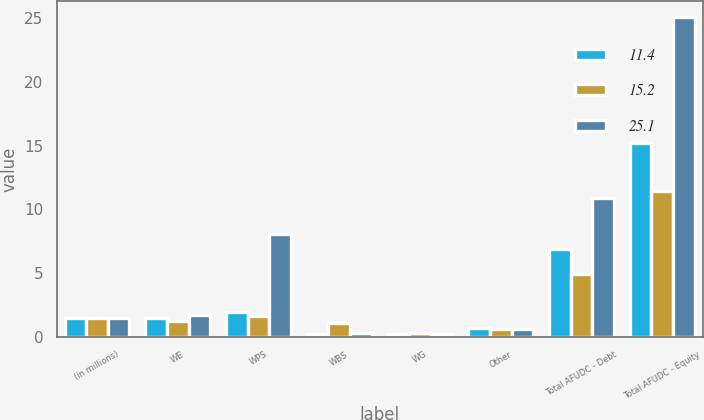Convert chart. <chart><loc_0><loc_0><loc_500><loc_500><stacked_bar_chart><ecel><fcel>(in millions)<fcel>WE<fcel>WPS<fcel>WBS<fcel>WG<fcel>Other<fcel>Total AFUDC - Debt<fcel>Total AFUDC - Equity<nl><fcel>11.4<fcel>1.5<fcel>1.5<fcel>1.9<fcel>0.2<fcel>0.2<fcel>0.7<fcel>6.9<fcel>15.2<nl><fcel>15.2<fcel>1.5<fcel>1.2<fcel>1.6<fcel>1.1<fcel>0.3<fcel>0.6<fcel>4.9<fcel>11.4<nl><fcel>25.1<fcel>1.5<fcel>1.7<fcel>8.1<fcel>0.3<fcel>0.2<fcel>0.6<fcel>10.9<fcel>25.1<nl></chart> 